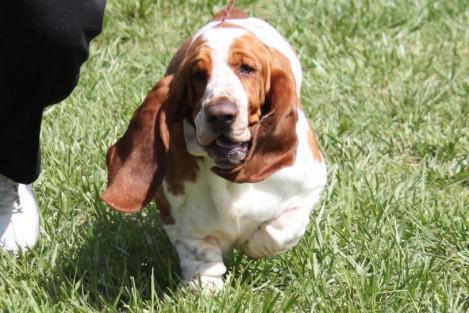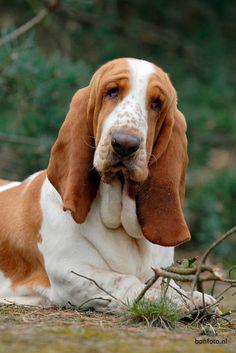The first image is the image on the left, the second image is the image on the right. For the images displayed, is the sentence "A floppy eared dog is moving forward across the grass in one image." factually correct? Answer yes or no. Yes. The first image is the image on the left, the second image is the image on the right. Assess this claim about the two images: "the dog appears to be moving in one of the images". Correct or not? Answer yes or no. Yes. 